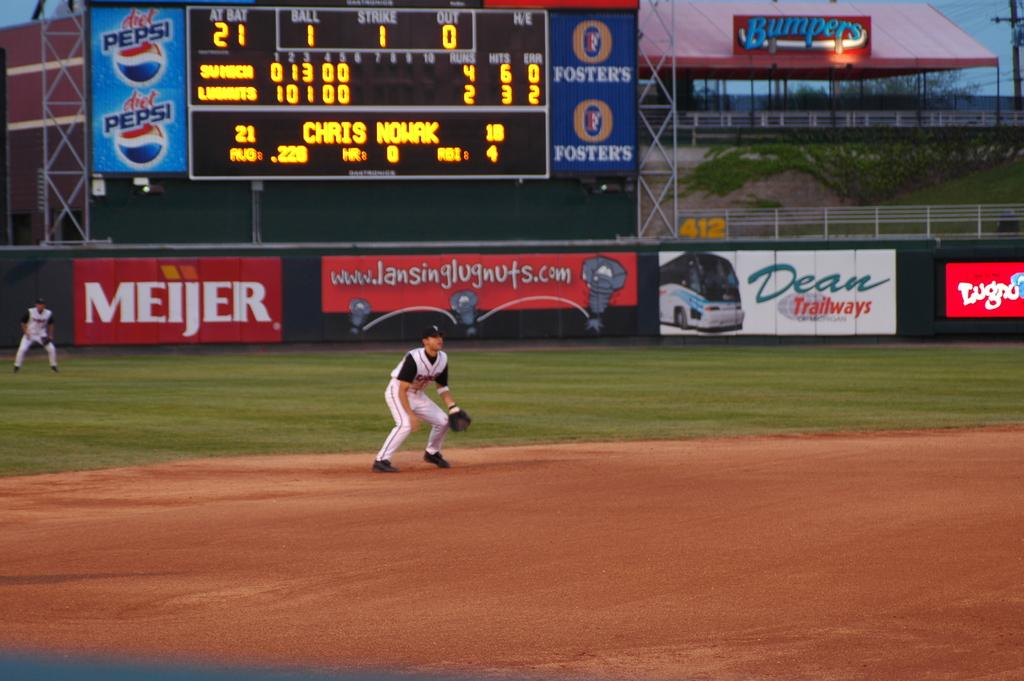<image>
Render a clear and concise summary of the photo. An ad for diet Pepsi appears to the left of the digital scoreboard. 